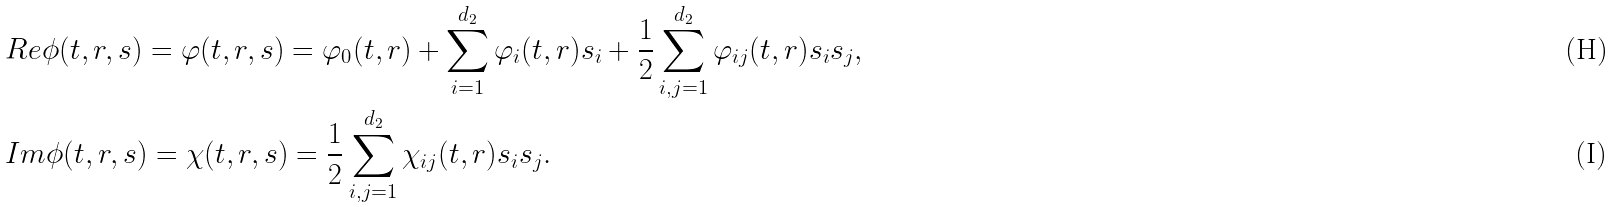Convert formula to latex. <formula><loc_0><loc_0><loc_500><loc_500>& R e \phi ( t , r , s ) = \varphi ( t , r , s ) = \varphi _ { 0 } ( t , r ) + \sum _ { i = 1 } ^ { d _ { 2 } } \varphi _ { i } ( t , r ) s _ { i } + \frac { 1 } { 2 } \sum _ { i , j = 1 } ^ { d _ { 2 } } \varphi _ { i j } ( t , r ) s _ { i } s _ { j } , \\ & I m \phi ( t , r , s ) = \chi ( t , r , s ) = \frac { 1 } { 2 } \sum _ { i , j = 1 } ^ { d _ { 2 } } \chi _ { i j } ( t , r ) s _ { i } s _ { j } .</formula> 